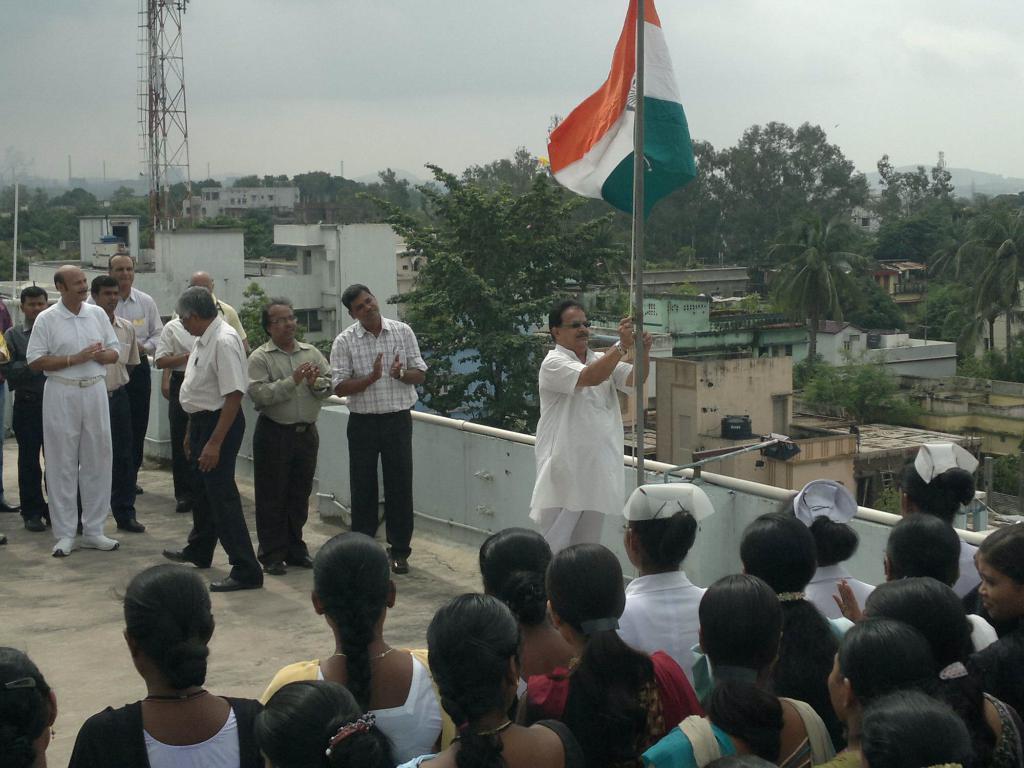Could you give a brief overview of what you see in this image? In this image we can see the mountains, one flag, one ladder, one water tank, so many poles, some objects are on the surface, one antenna, so many buildings and so many trees. At the top of the building so many people are standing, one person is holding flag thread and at the top there is the sky. 